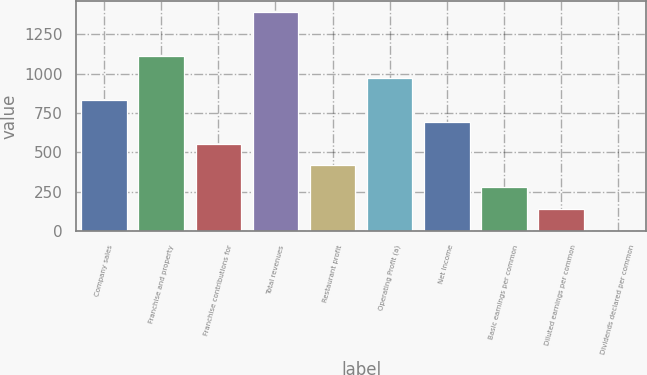<chart> <loc_0><loc_0><loc_500><loc_500><bar_chart><fcel>Company sales<fcel>Franchise and property<fcel>Franchise contributions for<fcel>Total revenues<fcel>Restaurant profit<fcel>Operating Profit (a)<fcel>Net Income<fcel>Basic earnings per common<fcel>Diluted earnings per common<fcel>Dividends declared per common<nl><fcel>834.72<fcel>1112.84<fcel>556.6<fcel>1391<fcel>417.54<fcel>973.78<fcel>695.66<fcel>278.48<fcel>139.42<fcel>0.36<nl></chart> 